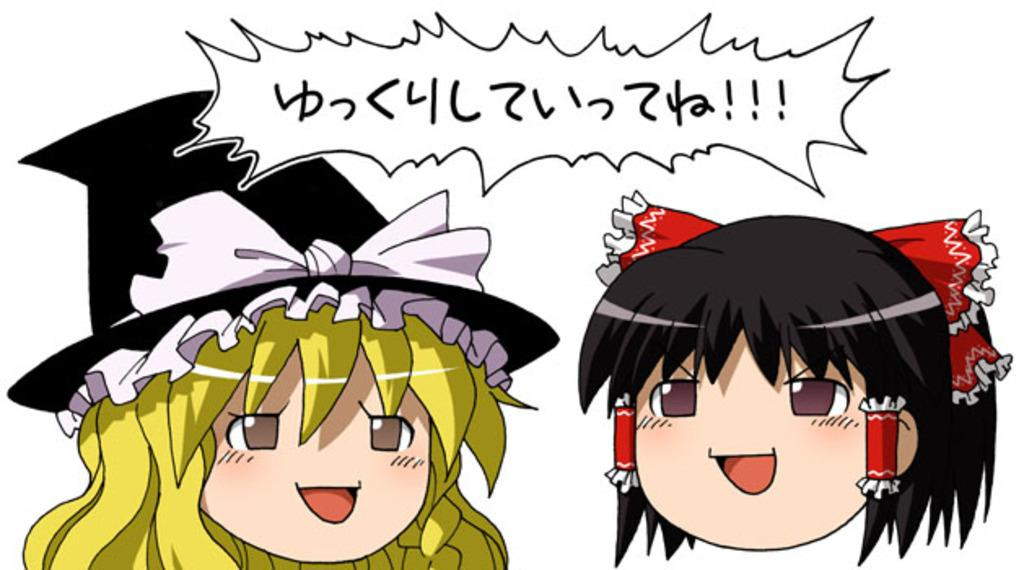Who is present in the image? There is a girl in the image. Can you describe the appearance of the other girl in the image? There is another girl wearing a black hat in the image. What can be seen at the top of the image? There is text at the top of the image. What color is the background of the image? The background of the image is white. What type of prison can be seen in the background of the image? There is no prison present in the image; the background is white. Can you tell me how many jars are visible on the table in the image? There is no table or jar present in the image. 